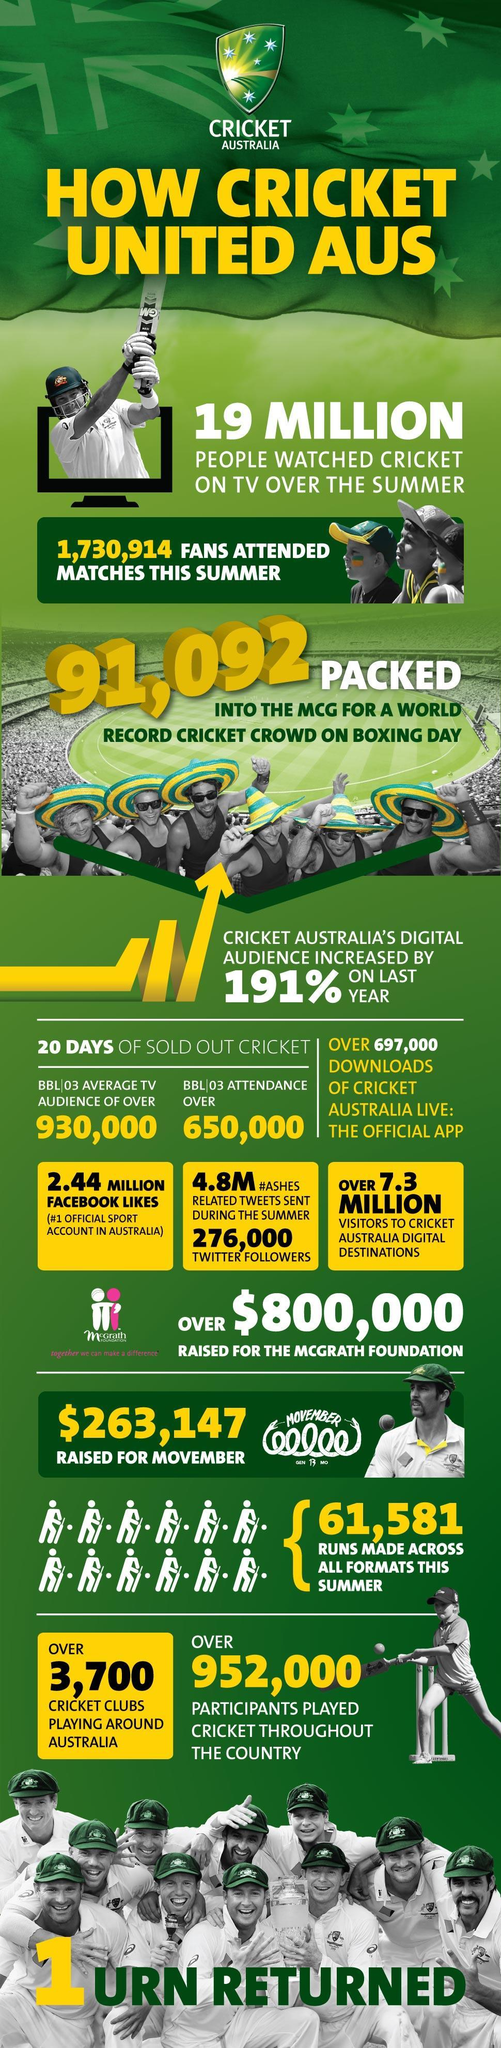How much is the support for Cricket Australia on Facebook?
Answer the question with a short phrase. 2.44  million How many people installed the Official Cricket Application of Australia? 697,000 How many cricket associations are there in Australia? Over 3,700 How many people witnessed the Australia match during the harvest? 1,730,914 